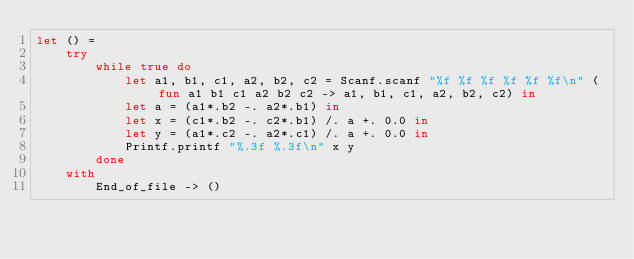Convert code to text. <code><loc_0><loc_0><loc_500><loc_500><_OCaml_>let () =
    try
        while true do
            let a1, b1, c1, a2, b2, c2 = Scanf.scanf "%f %f %f %f %f %f\n" (fun a1 b1 c1 a2 b2 c2 -> a1, b1, c1, a2, b2, c2) in
            let a = (a1*.b2 -. a2*.b1) in
            let x = (c1*.b2 -. c2*.b1) /. a +. 0.0 in
            let y = (a1*.c2 -. a2*.c1) /. a +. 0.0 in
            Printf.printf "%.3f %.3f\n" x y
        done
    with
        End_of_file -> ()</code> 